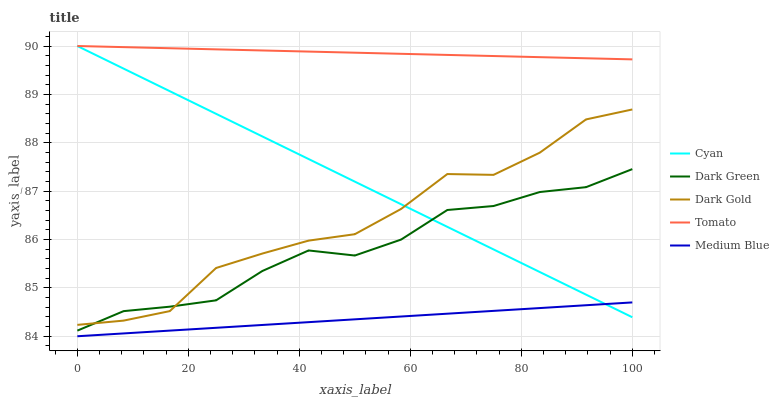Does Cyan have the minimum area under the curve?
Answer yes or no. No. Does Cyan have the maximum area under the curve?
Answer yes or no. No. Is Cyan the smoothest?
Answer yes or no. No. Is Cyan the roughest?
Answer yes or no. No. Does Cyan have the lowest value?
Answer yes or no. No. Does Dark Gold have the highest value?
Answer yes or no. No. Is Medium Blue less than Tomato?
Answer yes or no. Yes. Is Tomato greater than Medium Blue?
Answer yes or no. Yes. Does Medium Blue intersect Tomato?
Answer yes or no. No. 